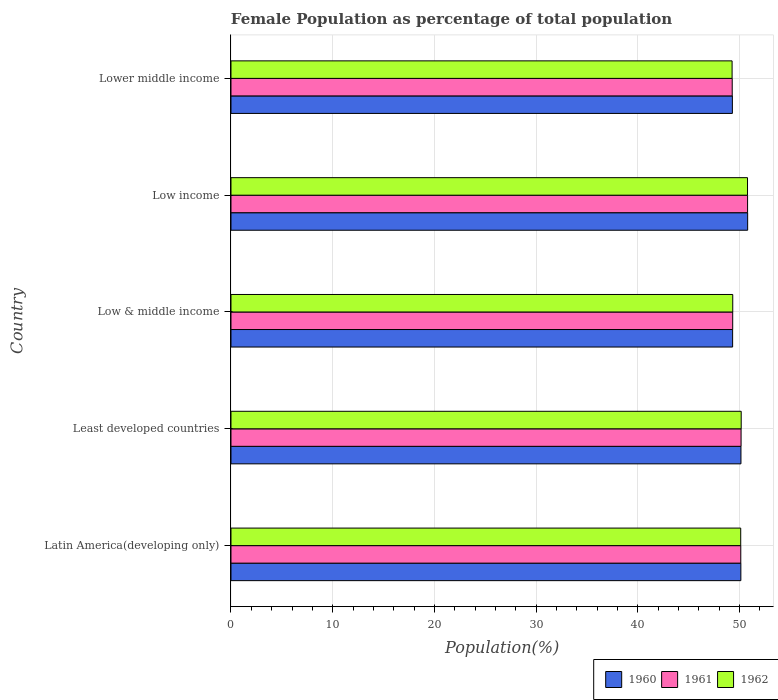How many different coloured bars are there?
Provide a succinct answer. 3. How many groups of bars are there?
Make the answer very short. 5. Are the number of bars per tick equal to the number of legend labels?
Make the answer very short. Yes. How many bars are there on the 5th tick from the bottom?
Offer a very short reply. 3. In how many cases, is the number of bars for a given country not equal to the number of legend labels?
Your answer should be very brief. 0. What is the female population in in 1962 in Latin America(developing only)?
Offer a very short reply. 50.11. Across all countries, what is the maximum female population in in 1960?
Provide a short and direct response. 50.79. Across all countries, what is the minimum female population in in 1961?
Keep it short and to the point. 49.28. In which country was the female population in in 1962 maximum?
Keep it short and to the point. Low income. In which country was the female population in in 1962 minimum?
Your answer should be very brief. Lower middle income. What is the total female population in in 1961 in the graph?
Make the answer very short. 249.65. What is the difference between the female population in in 1961 in Low & middle income and that in Low income?
Provide a succinct answer. -1.46. What is the difference between the female population in in 1962 in Latin America(developing only) and the female population in in 1960 in Low income?
Ensure brevity in your answer.  -0.68. What is the average female population in in 1962 per country?
Provide a short and direct response. 49.93. What is the difference between the female population in in 1960 and female population in in 1962 in Lower middle income?
Your response must be concise. 0.03. In how many countries, is the female population in in 1960 greater than 32 %?
Ensure brevity in your answer.  5. What is the ratio of the female population in in 1960 in Low & middle income to that in Low income?
Keep it short and to the point. 0.97. Is the female population in in 1961 in Low income less than that in Lower middle income?
Your answer should be compact. No. Is the difference between the female population in in 1960 in Least developed countries and Low income greater than the difference between the female population in in 1962 in Least developed countries and Low income?
Offer a terse response. No. What is the difference between the highest and the second highest female population in in 1962?
Make the answer very short. 0.62. What is the difference between the highest and the lowest female population in in 1960?
Keep it short and to the point. 1.5. What does the 1st bar from the bottom in Low & middle income represents?
Offer a very short reply. 1960. Are the values on the major ticks of X-axis written in scientific E-notation?
Keep it short and to the point. No. Does the graph contain any zero values?
Keep it short and to the point. No. Does the graph contain grids?
Ensure brevity in your answer.  Yes. What is the title of the graph?
Your answer should be very brief. Female Population as percentage of total population. What is the label or title of the X-axis?
Your answer should be compact. Population(%). What is the Population(%) of 1960 in Latin America(developing only)?
Offer a terse response. 50.13. What is the Population(%) of 1961 in Latin America(developing only)?
Make the answer very short. 50.12. What is the Population(%) of 1962 in Latin America(developing only)?
Make the answer very short. 50.11. What is the Population(%) in 1960 in Least developed countries?
Give a very brief answer. 50.13. What is the Population(%) of 1961 in Least developed countries?
Your response must be concise. 50.15. What is the Population(%) of 1962 in Least developed countries?
Keep it short and to the point. 50.16. What is the Population(%) of 1960 in Low & middle income?
Your answer should be compact. 49.31. What is the Population(%) of 1961 in Low & middle income?
Ensure brevity in your answer.  49.32. What is the Population(%) in 1962 in Low & middle income?
Your answer should be very brief. 49.33. What is the Population(%) in 1960 in Low income?
Keep it short and to the point. 50.79. What is the Population(%) in 1961 in Low income?
Your answer should be very brief. 50.79. What is the Population(%) of 1962 in Low income?
Offer a terse response. 50.78. What is the Population(%) in 1960 in Lower middle income?
Keep it short and to the point. 49.29. What is the Population(%) in 1961 in Lower middle income?
Your answer should be very brief. 49.28. What is the Population(%) of 1962 in Lower middle income?
Provide a succinct answer. 49.26. Across all countries, what is the maximum Population(%) of 1960?
Provide a short and direct response. 50.79. Across all countries, what is the maximum Population(%) in 1961?
Your answer should be very brief. 50.79. Across all countries, what is the maximum Population(%) of 1962?
Offer a terse response. 50.78. Across all countries, what is the minimum Population(%) of 1960?
Offer a very short reply. 49.29. Across all countries, what is the minimum Population(%) in 1961?
Keep it short and to the point. 49.28. Across all countries, what is the minimum Population(%) in 1962?
Offer a very short reply. 49.26. What is the total Population(%) of 1960 in the graph?
Provide a short and direct response. 249.66. What is the total Population(%) in 1961 in the graph?
Ensure brevity in your answer.  249.65. What is the total Population(%) of 1962 in the graph?
Provide a short and direct response. 249.64. What is the difference between the Population(%) in 1960 in Latin America(developing only) and that in Least developed countries?
Provide a succinct answer. -0.01. What is the difference between the Population(%) of 1961 in Latin America(developing only) and that in Least developed countries?
Make the answer very short. -0.03. What is the difference between the Population(%) of 1962 in Latin America(developing only) and that in Least developed countries?
Offer a terse response. -0.05. What is the difference between the Population(%) in 1960 in Latin America(developing only) and that in Low & middle income?
Make the answer very short. 0.81. What is the difference between the Population(%) of 1961 in Latin America(developing only) and that in Low & middle income?
Your response must be concise. 0.79. What is the difference between the Population(%) in 1962 in Latin America(developing only) and that in Low & middle income?
Your answer should be very brief. 0.78. What is the difference between the Population(%) of 1960 in Latin America(developing only) and that in Low income?
Keep it short and to the point. -0.67. What is the difference between the Population(%) of 1961 in Latin America(developing only) and that in Low income?
Your answer should be very brief. -0.67. What is the difference between the Population(%) in 1962 in Latin America(developing only) and that in Low income?
Provide a succinct answer. -0.67. What is the difference between the Population(%) in 1960 in Latin America(developing only) and that in Lower middle income?
Offer a very short reply. 0.84. What is the difference between the Population(%) in 1961 in Latin America(developing only) and that in Lower middle income?
Your response must be concise. 0.84. What is the difference between the Population(%) in 1962 in Latin America(developing only) and that in Lower middle income?
Make the answer very short. 0.85. What is the difference between the Population(%) of 1960 in Least developed countries and that in Low & middle income?
Your answer should be compact. 0.82. What is the difference between the Population(%) of 1961 in Least developed countries and that in Low & middle income?
Make the answer very short. 0.82. What is the difference between the Population(%) in 1962 in Least developed countries and that in Low & middle income?
Ensure brevity in your answer.  0.83. What is the difference between the Population(%) of 1960 in Least developed countries and that in Low income?
Keep it short and to the point. -0.66. What is the difference between the Population(%) in 1961 in Least developed countries and that in Low income?
Ensure brevity in your answer.  -0.64. What is the difference between the Population(%) of 1962 in Least developed countries and that in Low income?
Offer a very short reply. -0.62. What is the difference between the Population(%) of 1960 in Least developed countries and that in Lower middle income?
Keep it short and to the point. 0.84. What is the difference between the Population(%) of 1961 in Least developed countries and that in Lower middle income?
Offer a terse response. 0.87. What is the difference between the Population(%) in 1962 in Least developed countries and that in Lower middle income?
Make the answer very short. 0.89. What is the difference between the Population(%) of 1960 in Low & middle income and that in Low income?
Your answer should be very brief. -1.48. What is the difference between the Population(%) of 1961 in Low & middle income and that in Low income?
Your response must be concise. -1.46. What is the difference between the Population(%) of 1962 in Low & middle income and that in Low income?
Make the answer very short. -1.45. What is the difference between the Population(%) in 1960 in Low & middle income and that in Lower middle income?
Your response must be concise. 0.03. What is the difference between the Population(%) in 1961 in Low & middle income and that in Lower middle income?
Give a very brief answer. 0.05. What is the difference between the Population(%) in 1962 in Low & middle income and that in Lower middle income?
Provide a short and direct response. 0.06. What is the difference between the Population(%) of 1960 in Low income and that in Lower middle income?
Your response must be concise. 1.5. What is the difference between the Population(%) of 1961 in Low income and that in Lower middle income?
Offer a very short reply. 1.51. What is the difference between the Population(%) in 1962 in Low income and that in Lower middle income?
Offer a very short reply. 1.52. What is the difference between the Population(%) in 1960 in Latin America(developing only) and the Population(%) in 1961 in Least developed countries?
Provide a short and direct response. -0.02. What is the difference between the Population(%) in 1960 in Latin America(developing only) and the Population(%) in 1962 in Least developed countries?
Your answer should be very brief. -0.03. What is the difference between the Population(%) in 1961 in Latin America(developing only) and the Population(%) in 1962 in Least developed countries?
Provide a short and direct response. -0.04. What is the difference between the Population(%) in 1960 in Latin America(developing only) and the Population(%) in 1961 in Low & middle income?
Ensure brevity in your answer.  0.8. What is the difference between the Population(%) in 1960 in Latin America(developing only) and the Population(%) in 1962 in Low & middle income?
Provide a short and direct response. 0.8. What is the difference between the Population(%) in 1961 in Latin America(developing only) and the Population(%) in 1962 in Low & middle income?
Make the answer very short. 0.79. What is the difference between the Population(%) of 1960 in Latin America(developing only) and the Population(%) of 1961 in Low income?
Your answer should be very brief. -0.66. What is the difference between the Population(%) in 1960 in Latin America(developing only) and the Population(%) in 1962 in Low income?
Keep it short and to the point. -0.65. What is the difference between the Population(%) in 1961 in Latin America(developing only) and the Population(%) in 1962 in Low income?
Provide a short and direct response. -0.66. What is the difference between the Population(%) in 1960 in Latin America(developing only) and the Population(%) in 1961 in Lower middle income?
Your answer should be very brief. 0.85. What is the difference between the Population(%) in 1960 in Latin America(developing only) and the Population(%) in 1962 in Lower middle income?
Offer a very short reply. 0.86. What is the difference between the Population(%) of 1961 in Latin America(developing only) and the Population(%) of 1962 in Lower middle income?
Provide a succinct answer. 0.85. What is the difference between the Population(%) in 1960 in Least developed countries and the Population(%) in 1961 in Low & middle income?
Give a very brief answer. 0.81. What is the difference between the Population(%) in 1960 in Least developed countries and the Population(%) in 1962 in Low & middle income?
Offer a terse response. 0.81. What is the difference between the Population(%) of 1961 in Least developed countries and the Population(%) of 1962 in Low & middle income?
Offer a terse response. 0.82. What is the difference between the Population(%) of 1960 in Least developed countries and the Population(%) of 1961 in Low income?
Ensure brevity in your answer.  -0.65. What is the difference between the Population(%) of 1960 in Least developed countries and the Population(%) of 1962 in Low income?
Your answer should be very brief. -0.65. What is the difference between the Population(%) in 1961 in Least developed countries and the Population(%) in 1962 in Low income?
Offer a very short reply. -0.63. What is the difference between the Population(%) of 1960 in Least developed countries and the Population(%) of 1961 in Lower middle income?
Your answer should be compact. 0.86. What is the difference between the Population(%) of 1960 in Least developed countries and the Population(%) of 1962 in Lower middle income?
Your answer should be compact. 0.87. What is the difference between the Population(%) in 1961 in Least developed countries and the Population(%) in 1962 in Lower middle income?
Offer a terse response. 0.88. What is the difference between the Population(%) in 1960 in Low & middle income and the Population(%) in 1961 in Low income?
Offer a very short reply. -1.47. What is the difference between the Population(%) in 1960 in Low & middle income and the Population(%) in 1962 in Low income?
Offer a terse response. -1.46. What is the difference between the Population(%) in 1961 in Low & middle income and the Population(%) in 1962 in Low income?
Your response must be concise. -1.46. What is the difference between the Population(%) in 1960 in Low & middle income and the Population(%) in 1961 in Lower middle income?
Give a very brief answer. 0.04. What is the difference between the Population(%) in 1960 in Low & middle income and the Population(%) in 1962 in Lower middle income?
Make the answer very short. 0.05. What is the difference between the Population(%) in 1961 in Low & middle income and the Population(%) in 1962 in Lower middle income?
Make the answer very short. 0.06. What is the difference between the Population(%) of 1960 in Low income and the Population(%) of 1961 in Lower middle income?
Your answer should be very brief. 1.52. What is the difference between the Population(%) in 1960 in Low income and the Population(%) in 1962 in Lower middle income?
Provide a short and direct response. 1.53. What is the difference between the Population(%) of 1961 in Low income and the Population(%) of 1962 in Lower middle income?
Keep it short and to the point. 1.52. What is the average Population(%) in 1960 per country?
Offer a very short reply. 49.93. What is the average Population(%) of 1961 per country?
Make the answer very short. 49.93. What is the average Population(%) of 1962 per country?
Your response must be concise. 49.93. What is the difference between the Population(%) in 1960 and Population(%) in 1961 in Latin America(developing only)?
Keep it short and to the point. 0.01. What is the difference between the Population(%) in 1960 and Population(%) in 1962 in Latin America(developing only)?
Ensure brevity in your answer.  0.01. What is the difference between the Population(%) of 1961 and Population(%) of 1962 in Latin America(developing only)?
Offer a terse response. 0.01. What is the difference between the Population(%) in 1960 and Population(%) in 1961 in Least developed countries?
Give a very brief answer. -0.01. What is the difference between the Population(%) in 1960 and Population(%) in 1962 in Least developed countries?
Ensure brevity in your answer.  -0.02. What is the difference between the Population(%) of 1961 and Population(%) of 1962 in Least developed countries?
Your answer should be compact. -0.01. What is the difference between the Population(%) of 1960 and Population(%) of 1961 in Low & middle income?
Offer a very short reply. -0.01. What is the difference between the Population(%) of 1960 and Population(%) of 1962 in Low & middle income?
Provide a short and direct response. -0.01. What is the difference between the Population(%) of 1961 and Population(%) of 1962 in Low & middle income?
Give a very brief answer. -0. What is the difference between the Population(%) of 1960 and Population(%) of 1961 in Low income?
Make the answer very short. 0.01. What is the difference between the Population(%) of 1960 and Population(%) of 1962 in Low income?
Your response must be concise. 0.01. What is the difference between the Population(%) in 1961 and Population(%) in 1962 in Low income?
Your response must be concise. 0.01. What is the difference between the Population(%) in 1960 and Population(%) in 1961 in Lower middle income?
Your answer should be very brief. 0.01. What is the difference between the Population(%) of 1960 and Population(%) of 1962 in Lower middle income?
Your answer should be compact. 0.03. What is the difference between the Population(%) in 1961 and Population(%) in 1962 in Lower middle income?
Your answer should be compact. 0.01. What is the ratio of the Population(%) in 1960 in Latin America(developing only) to that in Least developed countries?
Ensure brevity in your answer.  1. What is the ratio of the Population(%) in 1960 in Latin America(developing only) to that in Low & middle income?
Offer a very short reply. 1.02. What is the ratio of the Population(%) in 1961 in Latin America(developing only) to that in Low & middle income?
Your answer should be compact. 1.02. What is the ratio of the Population(%) in 1962 in Latin America(developing only) to that in Low & middle income?
Offer a very short reply. 1.02. What is the ratio of the Population(%) of 1960 in Latin America(developing only) to that in Low income?
Offer a terse response. 0.99. What is the ratio of the Population(%) in 1960 in Latin America(developing only) to that in Lower middle income?
Give a very brief answer. 1.02. What is the ratio of the Population(%) in 1961 in Latin America(developing only) to that in Lower middle income?
Offer a terse response. 1.02. What is the ratio of the Population(%) in 1962 in Latin America(developing only) to that in Lower middle income?
Provide a succinct answer. 1.02. What is the ratio of the Population(%) of 1960 in Least developed countries to that in Low & middle income?
Your answer should be very brief. 1.02. What is the ratio of the Population(%) in 1961 in Least developed countries to that in Low & middle income?
Keep it short and to the point. 1.02. What is the ratio of the Population(%) in 1962 in Least developed countries to that in Low & middle income?
Offer a terse response. 1.02. What is the ratio of the Population(%) of 1960 in Least developed countries to that in Low income?
Offer a terse response. 0.99. What is the ratio of the Population(%) of 1961 in Least developed countries to that in Low income?
Keep it short and to the point. 0.99. What is the ratio of the Population(%) in 1960 in Least developed countries to that in Lower middle income?
Offer a very short reply. 1.02. What is the ratio of the Population(%) of 1961 in Least developed countries to that in Lower middle income?
Your response must be concise. 1.02. What is the ratio of the Population(%) of 1962 in Least developed countries to that in Lower middle income?
Give a very brief answer. 1.02. What is the ratio of the Population(%) in 1960 in Low & middle income to that in Low income?
Provide a succinct answer. 0.97. What is the ratio of the Population(%) in 1961 in Low & middle income to that in Low income?
Give a very brief answer. 0.97. What is the ratio of the Population(%) in 1962 in Low & middle income to that in Low income?
Your answer should be very brief. 0.97. What is the ratio of the Population(%) of 1961 in Low & middle income to that in Lower middle income?
Ensure brevity in your answer.  1. What is the ratio of the Population(%) of 1962 in Low & middle income to that in Lower middle income?
Your response must be concise. 1. What is the ratio of the Population(%) in 1960 in Low income to that in Lower middle income?
Your answer should be compact. 1.03. What is the ratio of the Population(%) in 1961 in Low income to that in Lower middle income?
Your response must be concise. 1.03. What is the ratio of the Population(%) of 1962 in Low income to that in Lower middle income?
Offer a very short reply. 1.03. What is the difference between the highest and the second highest Population(%) in 1960?
Your response must be concise. 0.66. What is the difference between the highest and the second highest Population(%) of 1961?
Offer a very short reply. 0.64. What is the difference between the highest and the second highest Population(%) of 1962?
Keep it short and to the point. 0.62. What is the difference between the highest and the lowest Population(%) in 1960?
Provide a succinct answer. 1.5. What is the difference between the highest and the lowest Population(%) in 1961?
Make the answer very short. 1.51. What is the difference between the highest and the lowest Population(%) of 1962?
Your response must be concise. 1.52. 